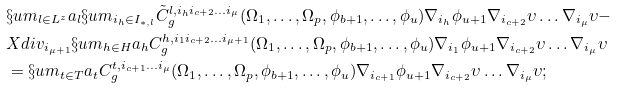Convert formula to latex. <formula><loc_0><loc_0><loc_500><loc_500>& \S u m _ { l \in L ^ { z } } a _ { l } \S u m _ { i _ { h } \in I _ { * , l } } \tilde { C } ^ { l , i _ { h } i _ { c + 2 } \dots i _ { \mu } } _ { g } ( \Omega _ { 1 } , \dots , \Omega _ { p } , \phi _ { b + 1 } , \dots , \phi _ { u } ) \nabla _ { i _ { h } } \phi _ { u + 1 } \nabla _ { i _ { c + 2 } } \upsilon \dots \nabla _ { i _ { \mu } } \upsilon - \\ & X d i v _ { i _ { \mu + 1 } } \S u m _ { h \in H } a _ { h } C ^ { h , i _ { 1 } i _ { c + 2 } \dots i _ { \mu + 1 } } _ { g } ( \Omega _ { 1 } , \dots , \Omega _ { p } , \phi _ { b + 1 } , \dots , \phi _ { u } ) \nabla _ { i _ { 1 } } \phi _ { u + 1 } \nabla _ { i _ { c + 2 } } \upsilon \dots \nabla _ { i _ { \mu } } \upsilon \\ & = \S u m _ { t \in T } a _ { t } C ^ { t , i _ { c + 1 } \dots i _ { \mu } } _ { g } ( \Omega _ { 1 } , \dots , \Omega _ { p } , \phi _ { b + 1 } , \dots , \phi _ { u } ) \nabla _ { i _ { c + 1 } } \phi _ { u + 1 } \nabla _ { i _ { c + 2 } } \upsilon \dots \nabla _ { i _ { \mu } } \upsilon ;</formula> 